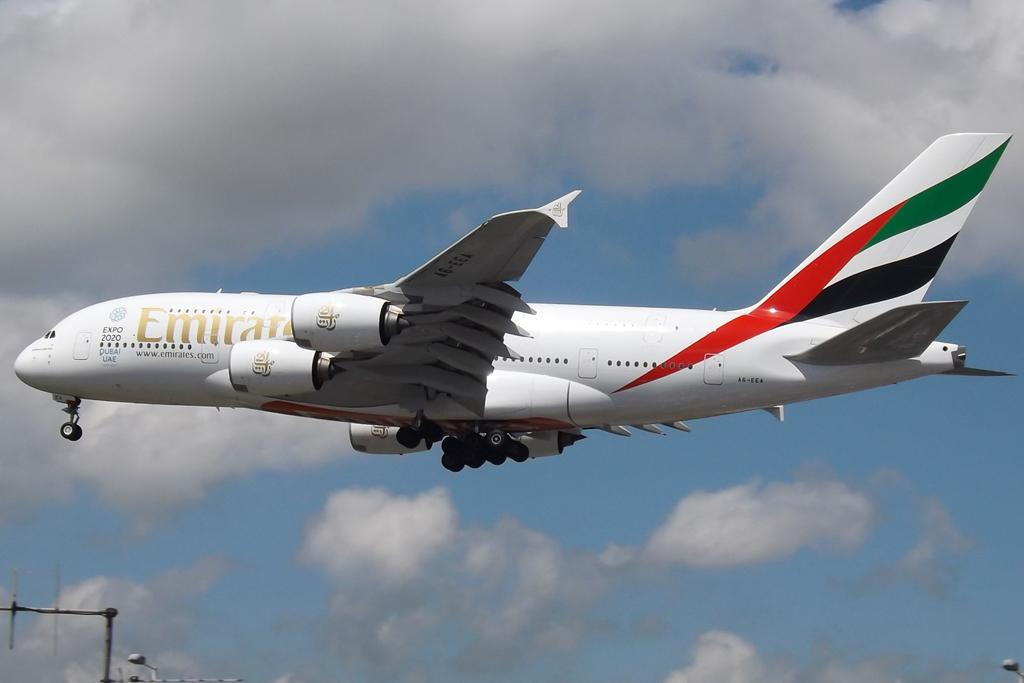Provide a one-sentence caption for the provided image. a large Emirite plane is flying through a cloudy sky. 